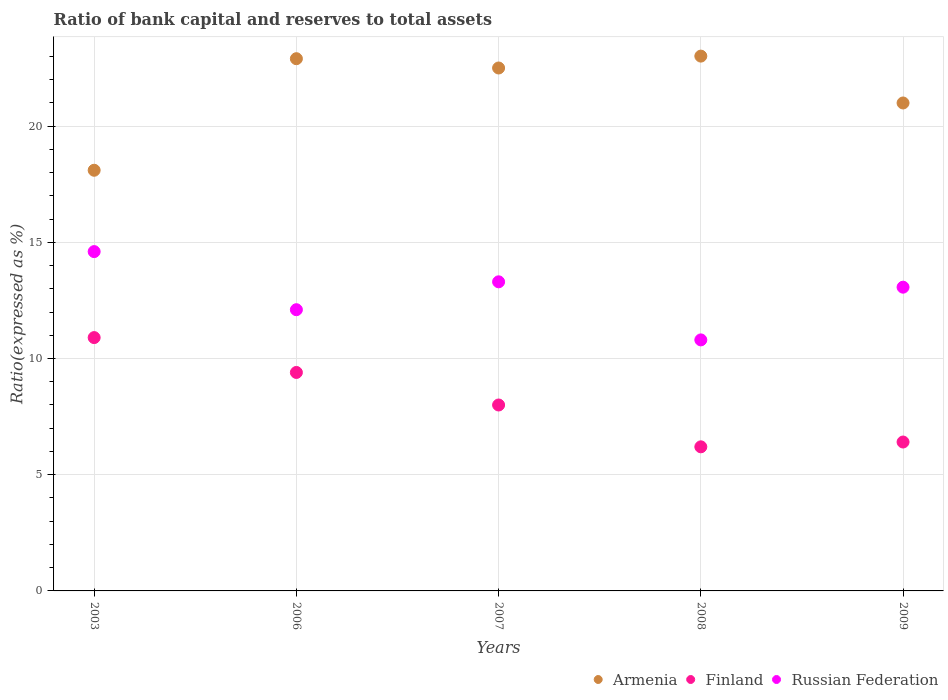How many different coloured dotlines are there?
Make the answer very short. 3. What is the ratio of bank capital and reserves to total assets in Russian Federation in 2006?
Ensure brevity in your answer.  12.1. Across all years, what is the minimum ratio of bank capital and reserves to total assets in Finland?
Provide a succinct answer. 6.2. What is the total ratio of bank capital and reserves to total assets in Finland in the graph?
Provide a succinct answer. 40.91. What is the difference between the ratio of bank capital and reserves to total assets in Finland in 2008 and that in 2009?
Keep it short and to the point. -0.21. What is the difference between the ratio of bank capital and reserves to total assets in Finland in 2009 and the ratio of bank capital and reserves to total assets in Russian Federation in 2008?
Give a very brief answer. -4.39. What is the average ratio of bank capital and reserves to total assets in Russian Federation per year?
Provide a succinct answer. 12.77. In the year 2009, what is the difference between the ratio of bank capital and reserves to total assets in Armenia and ratio of bank capital and reserves to total assets in Russian Federation?
Make the answer very short. 7.93. In how many years, is the ratio of bank capital and reserves to total assets in Russian Federation greater than 15 %?
Your answer should be very brief. 0. What is the ratio of the ratio of bank capital and reserves to total assets in Finland in 2006 to that in 2007?
Offer a very short reply. 1.18. Is the difference between the ratio of bank capital and reserves to total assets in Armenia in 2006 and 2007 greater than the difference between the ratio of bank capital and reserves to total assets in Russian Federation in 2006 and 2007?
Your response must be concise. Yes. What is the difference between the highest and the second highest ratio of bank capital and reserves to total assets in Armenia?
Your answer should be compact. 0.11. What is the difference between the highest and the lowest ratio of bank capital and reserves to total assets in Armenia?
Offer a terse response. 4.91. Is the sum of the ratio of bank capital and reserves to total assets in Armenia in 2003 and 2009 greater than the maximum ratio of bank capital and reserves to total assets in Finland across all years?
Offer a very short reply. Yes. Does the ratio of bank capital and reserves to total assets in Finland monotonically increase over the years?
Keep it short and to the point. No. How many years are there in the graph?
Your response must be concise. 5. Are the values on the major ticks of Y-axis written in scientific E-notation?
Offer a very short reply. No. What is the title of the graph?
Your answer should be compact. Ratio of bank capital and reserves to total assets. Does "Paraguay" appear as one of the legend labels in the graph?
Provide a short and direct response. No. What is the label or title of the Y-axis?
Offer a terse response. Ratio(expressed as %). What is the Ratio(expressed as %) in Armenia in 2003?
Provide a succinct answer. 18.1. What is the Ratio(expressed as %) of Finland in 2003?
Make the answer very short. 10.9. What is the Ratio(expressed as %) in Russian Federation in 2003?
Make the answer very short. 14.6. What is the Ratio(expressed as %) in Armenia in 2006?
Keep it short and to the point. 22.9. What is the Ratio(expressed as %) in Armenia in 2007?
Provide a short and direct response. 22.5. What is the Ratio(expressed as %) of Finland in 2007?
Ensure brevity in your answer.  8. What is the Ratio(expressed as %) of Russian Federation in 2007?
Give a very brief answer. 13.3. What is the Ratio(expressed as %) of Armenia in 2008?
Ensure brevity in your answer.  23.01. What is the Ratio(expressed as %) of Russian Federation in 2008?
Offer a terse response. 10.8. What is the Ratio(expressed as %) in Armenia in 2009?
Your answer should be very brief. 20.99. What is the Ratio(expressed as %) of Finland in 2009?
Offer a terse response. 6.41. What is the Ratio(expressed as %) in Russian Federation in 2009?
Provide a succinct answer. 13.07. Across all years, what is the maximum Ratio(expressed as %) of Armenia?
Your answer should be compact. 23.01. Across all years, what is the maximum Ratio(expressed as %) in Finland?
Make the answer very short. 10.9. Across all years, what is the maximum Ratio(expressed as %) in Russian Federation?
Provide a succinct answer. 14.6. Across all years, what is the minimum Ratio(expressed as %) in Russian Federation?
Ensure brevity in your answer.  10.8. What is the total Ratio(expressed as %) in Armenia in the graph?
Provide a short and direct response. 107.51. What is the total Ratio(expressed as %) in Finland in the graph?
Offer a very short reply. 40.91. What is the total Ratio(expressed as %) of Russian Federation in the graph?
Offer a very short reply. 63.87. What is the difference between the Ratio(expressed as %) of Finland in 2003 and that in 2006?
Provide a short and direct response. 1.5. What is the difference between the Ratio(expressed as %) in Russian Federation in 2003 and that in 2006?
Keep it short and to the point. 2.5. What is the difference between the Ratio(expressed as %) of Finland in 2003 and that in 2007?
Give a very brief answer. 2.9. What is the difference between the Ratio(expressed as %) in Armenia in 2003 and that in 2008?
Provide a succinct answer. -4.91. What is the difference between the Ratio(expressed as %) of Russian Federation in 2003 and that in 2008?
Make the answer very short. 3.8. What is the difference between the Ratio(expressed as %) of Armenia in 2003 and that in 2009?
Your answer should be very brief. -2.89. What is the difference between the Ratio(expressed as %) in Finland in 2003 and that in 2009?
Offer a terse response. 4.49. What is the difference between the Ratio(expressed as %) of Russian Federation in 2003 and that in 2009?
Your response must be concise. 1.53. What is the difference between the Ratio(expressed as %) of Armenia in 2006 and that in 2007?
Your answer should be compact. 0.4. What is the difference between the Ratio(expressed as %) in Armenia in 2006 and that in 2008?
Offer a very short reply. -0.11. What is the difference between the Ratio(expressed as %) in Finland in 2006 and that in 2008?
Your response must be concise. 3.2. What is the difference between the Ratio(expressed as %) in Russian Federation in 2006 and that in 2008?
Provide a short and direct response. 1.3. What is the difference between the Ratio(expressed as %) in Armenia in 2006 and that in 2009?
Offer a very short reply. 1.91. What is the difference between the Ratio(expressed as %) of Finland in 2006 and that in 2009?
Your response must be concise. 2.99. What is the difference between the Ratio(expressed as %) of Russian Federation in 2006 and that in 2009?
Offer a terse response. -0.97. What is the difference between the Ratio(expressed as %) in Armenia in 2007 and that in 2008?
Offer a terse response. -0.51. What is the difference between the Ratio(expressed as %) of Finland in 2007 and that in 2008?
Your answer should be very brief. 1.8. What is the difference between the Ratio(expressed as %) in Russian Federation in 2007 and that in 2008?
Your answer should be very brief. 2.5. What is the difference between the Ratio(expressed as %) of Armenia in 2007 and that in 2009?
Offer a terse response. 1.51. What is the difference between the Ratio(expressed as %) of Finland in 2007 and that in 2009?
Your answer should be very brief. 1.59. What is the difference between the Ratio(expressed as %) in Russian Federation in 2007 and that in 2009?
Make the answer very short. 0.23. What is the difference between the Ratio(expressed as %) in Armenia in 2008 and that in 2009?
Your answer should be very brief. 2.02. What is the difference between the Ratio(expressed as %) in Finland in 2008 and that in 2009?
Make the answer very short. -0.21. What is the difference between the Ratio(expressed as %) of Russian Federation in 2008 and that in 2009?
Provide a succinct answer. -2.27. What is the difference between the Ratio(expressed as %) in Armenia in 2003 and the Ratio(expressed as %) in Finland in 2006?
Give a very brief answer. 8.7. What is the difference between the Ratio(expressed as %) in Armenia in 2003 and the Ratio(expressed as %) in Russian Federation in 2006?
Provide a short and direct response. 6. What is the difference between the Ratio(expressed as %) in Finland in 2003 and the Ratio(expressed as %) in Russian Federation in 2006?
Provide a short and direct response. -1.2. What is the difference between the Ratio(expressed as %) of Armenia in 2003 and the Ratio(expressed as %) of Russian Federation in 2007?
Offer a terse response. 4.8. What is the difference between the Ratio(expressed as %) in Finland in 2003 and the Ratio(expressed as %) in Russian Federation in 2007?
Offer a very short reply. -2.4. What is the difference between the Ratio(expressed as %) of Armenia in 2003 and the Ratio(expressed as %) of Finland in 2008?
Ensure brevity in your answer.  11.9. What is the difference between the Ratio(expressed as %) in Armenia in 2003 and the Ratio(expressed as %) in Russian Federation in 2008?
Your answer should be very brief. 7.3. What is the difference between the Ratio(expressed as %) in Finland in 2003 and the Ratio(expressed as %) in Russian Federation in 2008?
Offer a very short reply. 0.1. What is the difference between the Ratio(expressed as %) of Armenia in 2003 and the Ratio(expressed as %) of Finland in 2009?
Your response must be concise. 11.69. What is the difference between the Ratio(expressed as %) of Armenia in 2003 and the Ratio(expressed as %) of Russian Federation in 2009?
Ensure brevity in your answer.  5.03. What is the difference between the Ratio(expressed as %) in Finland in 2003 and the Ratio(expressed as %) in Russian Federation in 2009?
Your response must be concise. -2.17. What is the difference between the Ratio(expressed as %) in Armenia in 2006 and the Ratio(expressed as %) in Finland in 2007?
Your answer should be very brief. 14.9. What is the difference between the Ratio(expressed as %) in Armenia in 2006 and the Ratio(expressed as %) in Finland in 2008?
Make the answer very short. 16.7. What is the difference between the Ratio(expressed as %) of Armenia in 2006 and the Ratio(expressed as %) of Russian Federation in 2008?
Your response must be concise. 12.1. What is the difference between the Ratio(expressed as %) of Finland in 2006 and the Ratio(expressed as %) of Russian Federation in 2008?
Your answer should be compact. -1.4. What is the difference between the Ratio(expressed as %) in Armenia in 2006 and the Ratio(expressed as %) in Finland in 2009?
Offer a very short reply. 16.49. What is the difference between the Ratio(expressed as %) of Armenia in 2006 and the Ratio(expressed as %) of Russian Federation in 2009?
Offer a very short reply. 9.83. What is the difference between the Ratio(expressed as %) of Finland in 2006 and the Ratio(expressed as %) of Russian Federation in 2009?
Offer a terse response. -3.67. What is the difference between the Ratio(expressed as %) of Armenia in 2007 and the Ratio(expressed as %) of Finland in 2008?
Offer a terse response. 16.3. What is the difference between the Ratio(expressed as %) of Armenia in 2007 and the Ratio(expressed as %) of Russian Federation in 2008?
Provide a short and direct response. 11.7. What is the difference between the Ratio(expressed as %) of Finland in 2007 and the Ratio(expressed as %) of Russian Federation in 2008?
Make the answer very short. -2.8. What is the difference between the Ratio(expressed as %) in Armenia in 2007 and the Ratio(expressed as %) in Finland in 2009?
Give a very brief answer. 16.09. What is the difference between the Ratio(expressed as %) of Armenia in 2007 and the Ratio(expressed as %) of Russian Federation in 2009?
Offer a very short reply. 9.43. What is the difference between the Ratio(expressed as %) in Finland in 2007 and the Ratio(expressed as %) in Russian Federation in 2009?
Offer a terse response. -5.07. What is the difference between the Ratio(expressed as %) of Armenia in 2008 and the Ratio(expressed as %) of Finland in 2009?
Offer a terse response. 16.6. What is the difference between the Ratio(expressed as %) in Armenia in 2008 and the Ratio(expressed as %) in Russian Federation in 2009?
Offer a terse response. 9.94. What is the difference between the Ratio(expressed as %) in Finland in 2008 and the Ratio(expressed as %) in Russian Federation in 2009?
Provide a succinct answer. -6.87. What is the average Ratio(expressed as %) in Armenia per year?
Provide a short and direct response. 21.5. What is the average Ratio(expressed as %) of Finland per year?
Offer a terse response. 8.18. What is the average Ratio(expressed as %) of Russian Federation per year?
Your answer should be compact. 12.77. In the year 2003, what is the difference between the Ratio(expressed as %) in Armenia and Ratio(expressed as %) in Finland?
Give a very brief answer. 7.2. In the year 2006, what is the difference between the Ratio(expressed as %) in Armenia and Ratio(expressed as %) in Finland?
Your answer should be compact. 13.5. In the year 2006, what is the difference between the Ratio(expressed as %) of Finland and Ratio(expressed as %) of Russian Federation?
Ensure brevity in your answer.  -2.7. In the year 2007, what is the difference between the Ratio(expressed as %) of Armenia and Ratio(expressed as %) of Finland?
Keep it short and to the point. 14.5. In the year 2008, what is the difference between the Ratio(expressed as %) of Armenia and Ratio(expressed as %) of Finland?
Ensure brevity in your answer.  16.81. In the year 2008, what is the difference between the Ratio(expressed as %) of Armenia and Ratio(expressed as %) of Russian Federation?
Offer a terse response. 12.21. In the year 2008, what is the difference between the Ratio(expressed as %) in Finland and Ratio(expressed as %) in Russian Federation?
Your answer should be compact. -4.6. In the year 2009, what is the difference between the Ratio(expressed as %) in Armenia and Ratio(expressed as %) in Finland?
Make the answer very short. 14.59. In the year 2009, what is the difference between the Ratio(expressed as %) in Armenia and Ratio(expressed as %) in Russian Federation?
Offer a very short reply. 7.93. In the year 2009, what is the difference between the Ratio(expressed as %) of Finland and Ratio(expressed as %) of Russian Federation?
Your answer should be very brief. -6.66. What is the ratio of the Ratio(expressed as %) of Armenia in 2003 to that in 2006?
Keep it short and to the point. 0.79. What is the ratio of the Ratio(expressed as %) of Finland in 2003 to that in 2006?
Your answer should be very brief. 1.16. What is the ratio of the Ratio(expressed as %) in Russian Federation in 2003 to that in 2006?
Your answer should be very brief. 1.21. What is the ratio of the Ratio(expressed as %) of Armenia in 2003 to that in 2007?
Keep it short and to the point. 0.8. What is the ratio of the Ratio(expressed as %) of Finland in 2003 to that in 2007?
Ensure brevity in your answer.  1.36. What is the ratio of the Ratio(expressed as %) of Russian Federation in 2003 to that in 2007?
Your answer should be compact. 1.1. What is the ratio of the Ratio(expressed as %) in Armenia in 2003 to that in 2008?
Offer a very short reply. 0.79. What is the ratio of the Ratio(expressed as %) of Finland in 2003 to that in 2008?
Your response must be concise. 1.76. What is the ratio of the Ratio(expressed as %) of Russian Federation in 2003 to that in 2008?
Give a very brief answer. 1.35. What is the ratio of the Ratio(expressed as %) in Armenia in 2003 to that in 2009?
Ensure brevity in your answer.  0.86. What is the ratio of the Ratio(expressed as %) of Finland in 2003 to that in 2009?
Offer a terse response. 1.7. What is the ratio of the Ratio(expressed as %) in Russian Federation in 2003 to that in 2009?
Keep it short and to the point. 1.12. What is the ratio of the Ratio(expressed as %) in Armenia in 2006 to that in 2007?
Make the answer very short. 1.02. What is the ratio of the Ratio(expressed as %) of Finland in 2006 to that in 2007?
Make the answer very short. 1.18. What is the ratio of the Ratio(expressed as %) of Russian Federation in 2006 to that in 2007?
Keep it short and to the point. 0.91. What is the ratio of the Ratio(expressed as %) of Finland in 2006 to that in 2008?
Provide a succinct answer. 1.52. What is the ratio of the Ratio(expressed as %) of Russian Federation in 2006 to that in 2008?
Offer a terse response. 1.12. What is the ratio of the Ratio(expressed as %) of Armenia in 2006 to that in 2009?
Offer a terse response. 1.09. What is the ratio of the Ratio(expressed as %) of Finland in 2006 to that in 2009?
Make the answer very short. 1.47. What is the ratio of the Ratio(expressed as %) of Russian Federation in 2006 to that in 2009?
Provide a short and direct response. 0.93. What is the ratio of the Ratio(expressed as %) of Armenia in 2007 to that in 2008?
Ensure brevity in your answer.  0.98. What is the ratio of the Ratio(expressed as %) in Finland in 2007 to that in 2008?
Your answer should be compact. 1.29. What is the ratio of the Ratio(expressed as %) in Russian Federation in 2007 to that in 2008?
Your answer should be very brief. 1.23. What is the ratio of the Ratio(expressed as %) of Armenia in 2007 to that in 2009?
Give a very brief answer. 1.07. What is the ratio of the Ratio(expressed as %) in Finland in 2007 to that in 2009?
Your answer should be very brief. 1.25. What is the ratio of the Ratio(expressed as %) of Russian Federation in 2007 to that in 2009?
Provide a succinct answer. 1.02. What is the ratio of the Ratio(expressed as %) of Armenia in 2008 to that in 2009?
Make the answer very short. 1.1. What is the ratio of the Ratio(expressed as %) of Finland in 2008 to that in 2009?
Your answer should be very brief. 0.97. What is the ratio of the Ratio(expressed as %) in Russian Federation in 2008 to that in 2009?
Provide a short and direct response. 0.83. What is the difference between the highest and the second highest Ratio(expressed as %) of Armenia?
Your answer should be compact. 0.11. What is the difference between the highest and the lowest Ratio(expressed as %) in Armenia?
Keep it short and to the point. 4.91. What is the difference between the highest and the lowest Ratio(expressed as %) of Russian Federation?
Ensure brevity in your answer.  3.8. 